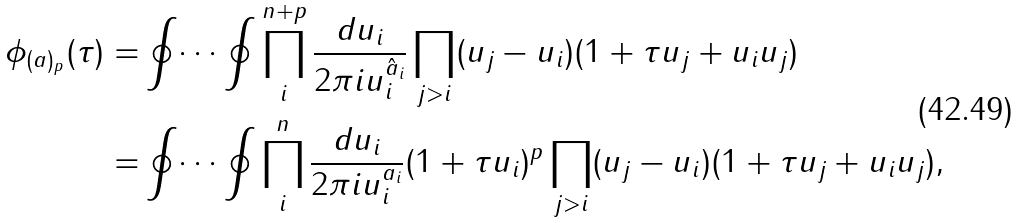Convert formula to latex. <formula><loc_0><loc_0><loc_500><loc_500>\phi _ { ( a ) _ { p } } ( \tau ) = & \oint \dots \oint \prod _ { i } ^ { n + p } \frac { d u _ { i } } { 2 \pi i u _ { i } ^ { \hat { a } _ { i } } } \prod _ { j > i } ( u _ { j } - u _ { i } ) ( 1 + \tau u _ { j } + u _ { i } u _ { j } ) \\ = & \oint \dots \oint \prod _ { i } ^ { n } \frac { d u _ { i } } { 2 \pi i u _ { i } ^ { a _ { i } } } ( 1 + \tau u _ { i } ) ^ { p } \prod _ { j > i } ( u _ { j } - u _ { i } ) ( 1 + \tau u _ { j } + u _ { i } u _ { j } ) ,</formula> 